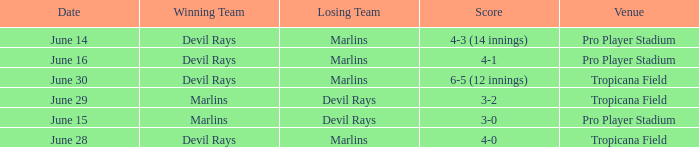What was the score on june 16? 4-1. 